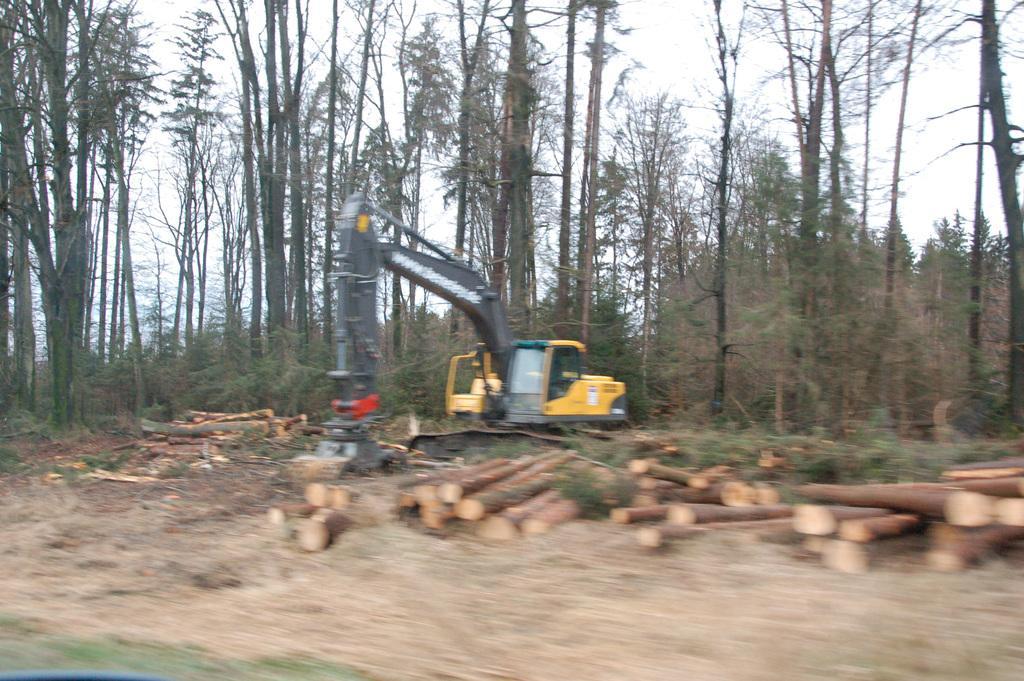How would you summarize this image in a sentence or two? On the ground there are wooden logs. Also there is an excavator. In the back there are many trees and sky. 